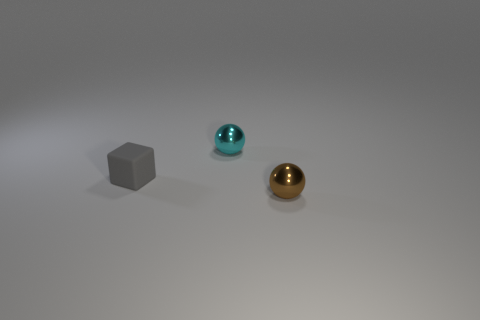What does the lighting in the scene suggest about the environment? The soft shadows and diffused light suggest an indoor setting, likely under artificial light such as a studio setup. The lack of harsh shadows or direct light sources indicates a controlled lighting environment, perhaps for the purpose of photography or display. Would these objects cast a shadow in a different lighting condition? Definitely. If exposed to a more intense or direct light source, each object would cast a more pronounced and sharp shadow, with the direction and length of the shadow depending on the angle and distance from the light source. 